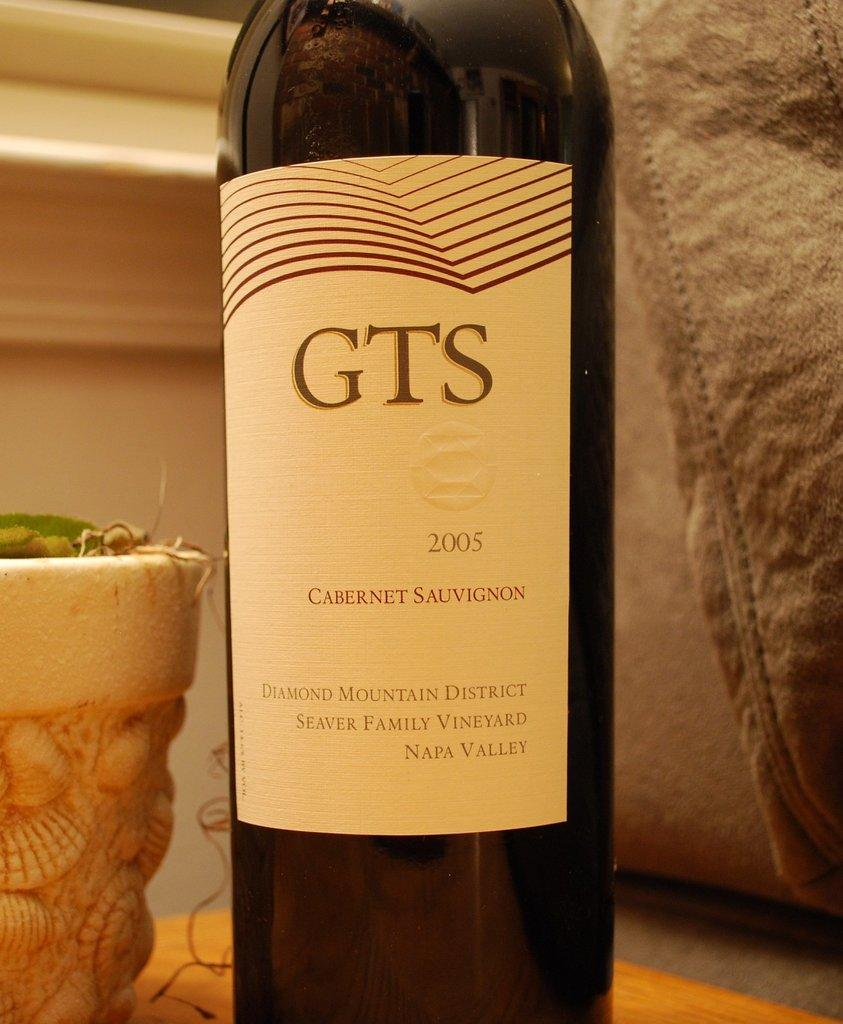<image>
Offer a succinct explanation of the picture presented. the letters GTS that is on the wine bottle 